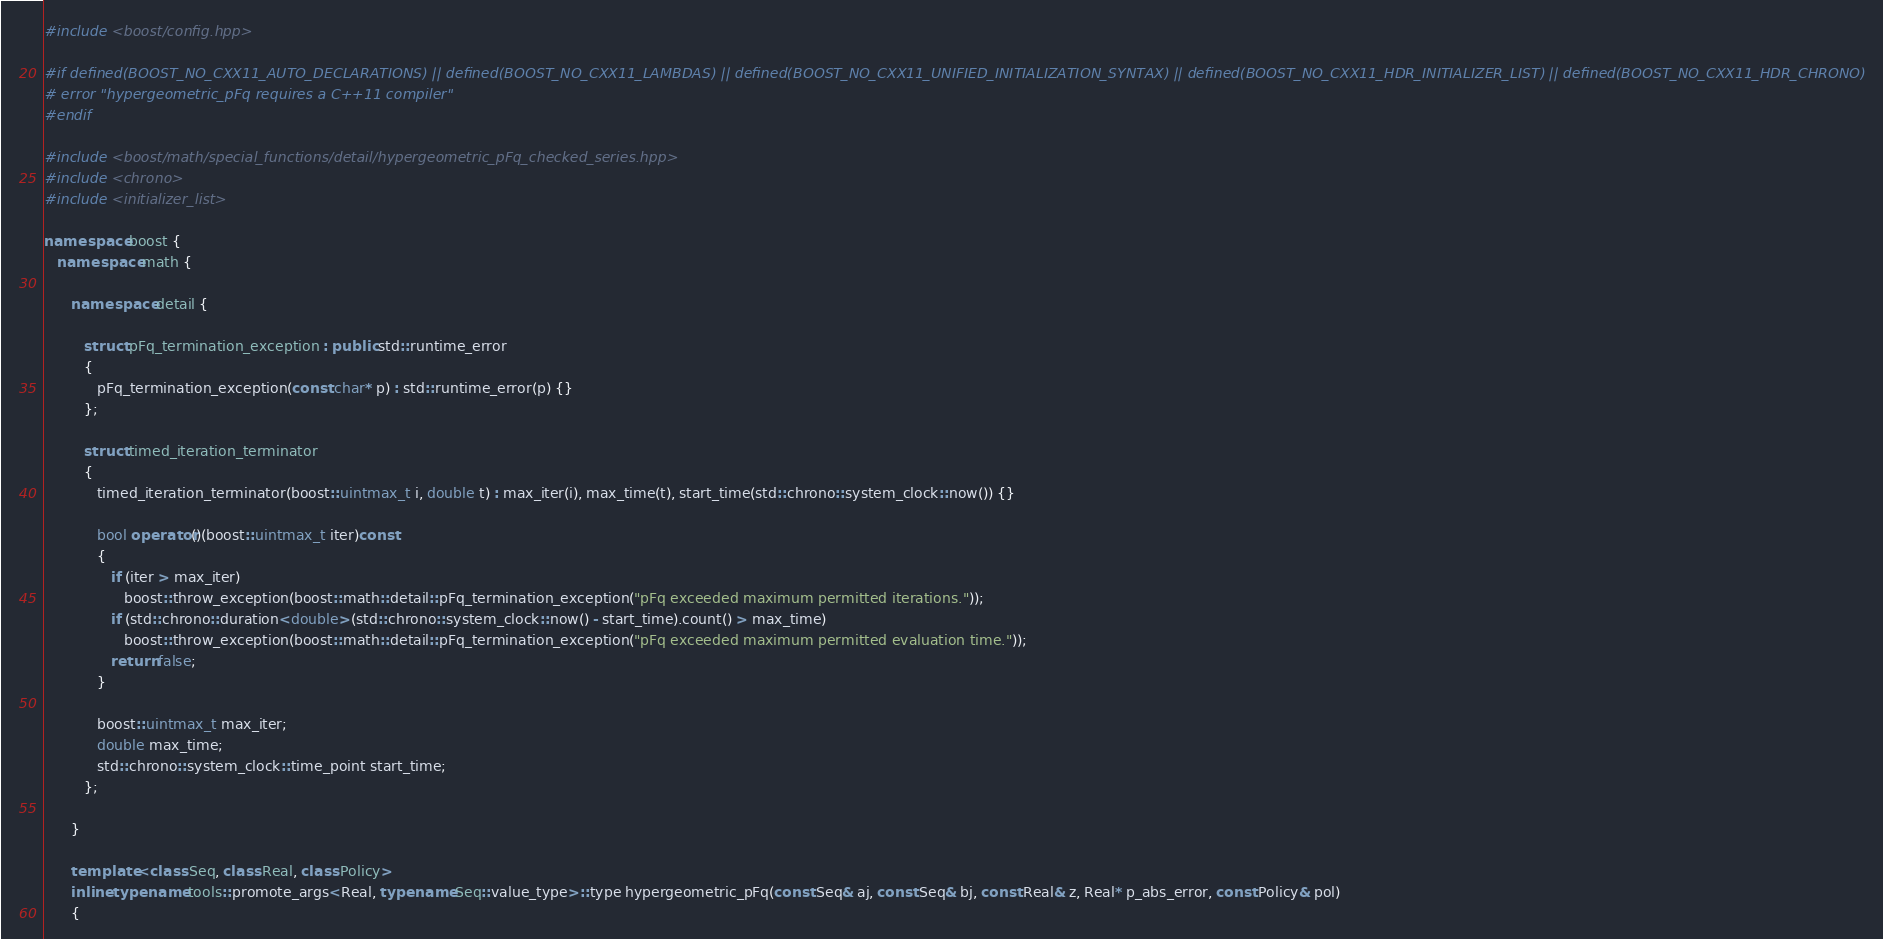Convert code to text. <code><loc_0><loc_0><loc_500><loc_500><_C++_>
#include <boost/config.hpp>

#if defined(BOOST_NO_CXX11_AUTO_DECLARATIONS) || defined(BOOST_NO_CXX11_LAMBDAS) || defined(BOOST_NO_CXX11_UNIFIED_INITIALIZATION_SYNTAX) || defined(BOOST_NO_CXX11_HDR_INITIALIZER_LIST) || defined(BOOST_NO_CXX11_HDR_CHRONO)
# error "hypergeometric_pFq requires a C++11 compiler"
#endif

#include <boost/math/special_functions/detail/hypergeometric_pFq_checked_series.hpp>
#include <chrono>
#include <initializer_list>

namespace boost {
   namespace math {

      namespace detail {

         struct pFq_termination_exception : public std::runtime_error
         {
            pFq_termination_exception(const char* p) : std::runtime_error(p) {}
         };

         struct timed_iteration_terminator
         {
            timed_iteration_terminator(boost::uintmax_t i, double t) : max_iter(i), max_time(t), start_time(std::chrono::system_clock::now()) {}

            bool operator()(boost::uintmax_t iter)const
            {
               if (iter > max_iter)
                  boost::throw_exception(boost::math::detail::pFq_termination_exception("pFq exceeded maximum permitted iterations."));
               if (std::chrono::duration<double>(std::chrono::system_clock::now() - start_time).count() > max_time)
                  boost::throw_exception(boost::math::detail::pFq_termination_exception("pFq exceeded maximum permitted evaluation time."));
               return false;
            }

            boost::uintmax_t max_iter;
            double max_time;
            std::chrono::system_clock::time_point start_time;
         };

      }

      template <class Seq, class Real, class Policy>
      inline typename tools::promote_args<Real, typename Seq::value_type>::type hypergeometric_pFq(const Seq& aj, const Seq& bj, const Real& z, Real* p_abs_error, const Policy& pol)
      {</code> 